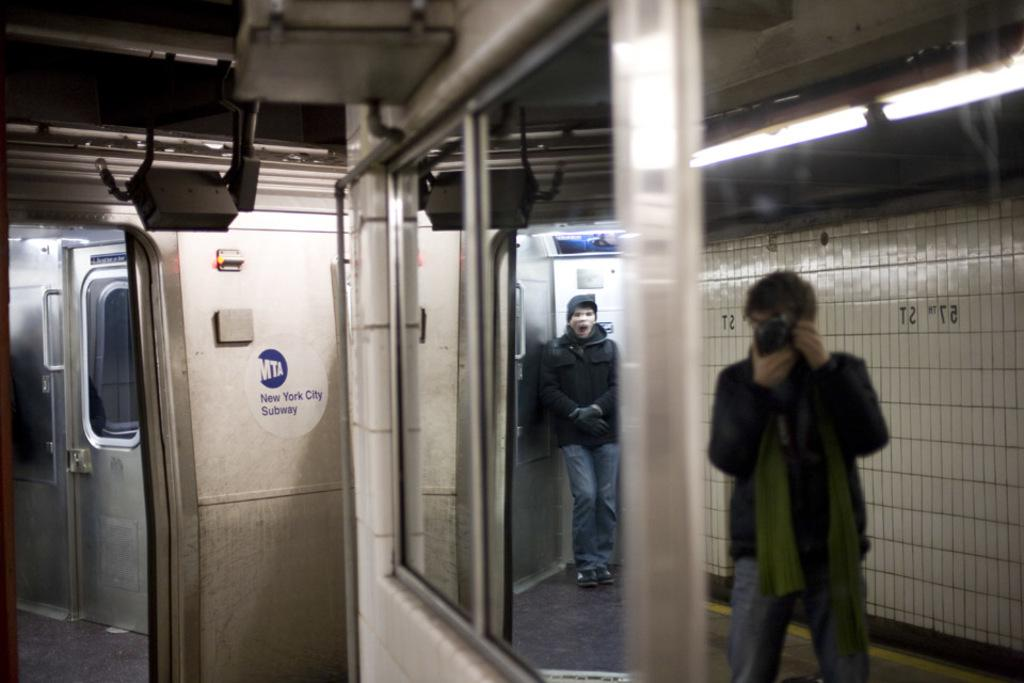<image>
Share a concise interpretation of the image provided. A view of the MTA New York Subway with someone taking a picture. 